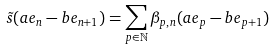Convert formula to latex. <formula><loc_0><loc_0><loc_500><loc_500>\tilde { s } ( a e _ { n } - b e _ { n + 1 } ) = \sum _ { p \in \mathbb { N } } \beta _ { p , n } ( a e _ { p } - b e _ { p + 1 } )</formula> 